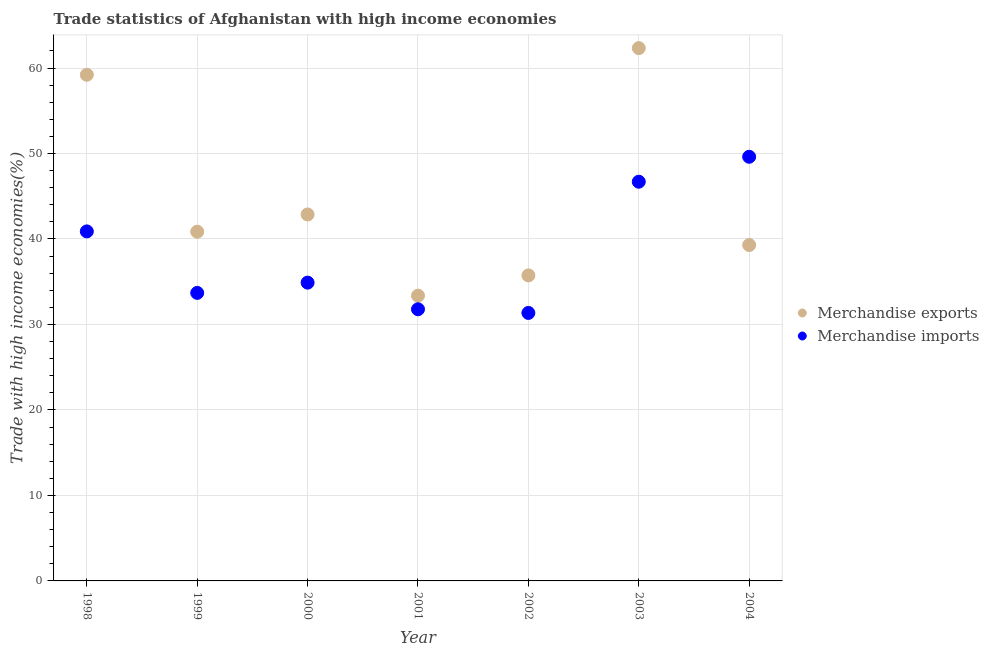Is the number of dotlines equal to the number of legend labels?
Offer a terse response. Yes. What is the merchandise exports in 2001?
Give a very brief answer. 33.37. Across all years, what is the maximum merchandise imports?
Offer a terse response. 49.62. Across all years, what is the minimum merchandise imports?
Offer a terse response. 31.35. In which year was the merchandise exports maximum?
Your response must be concise. 2003. In which year was the merchandise exports minimum?
Your response must be concise. 2001. What is the total merchandise exports in the graph?
Make the answer very short. 313.66. What is the difference between the merchandise exports in 1999 and that in 2000?
Make the answer very short. -2.02. What is the difference between the merchandise imports in 2002 and the merchandise exports in 2000?
Offer a very short reply. -11.52. What is the average merchandise imports per year?
Keep it short and to the point. 38.42. In the year 1999, what is the difference between the merchandise imports and merchandise exports?
Provide a succinct answer. -7.16. In how many years, is the merchandise imports greater than 34 %?
Make the answer very short. 4. What is the ratio of the merchandise imports in 1998 to that in 2000?
Provide a succinct answer. 1.17. Is the merchandise exports in 1999 less than that in 2003?
Your response must be concise. Yes. Is the difference between the merchandise imports in 1999 and 2004 greater than the difference between the merchandise exports in 1999 and 2004?
Ensure brevity in your answer.  No. What is the difference between the highest and the second highest merchandise imports?
Your answer should be very brief. 2.92. What is the difference between the highest and the lowest merchandise imports?
Offer a terse response. 18.27. How many dotlines are there?
Give a very brief answer. 2. How many years are there in the graph?
Keep it short and to the point. 7. What is the difference between two consecutive major ticks on the Y-axis?
Offer a very short reply. 10. Does the graph contain grids?
Your answer should be very brief. Yes. Where does the legend appear in the graph?
Offer a terse response. Center right. How many legend labels are there?
Your response must be concise. 2. What is the title of the graph?
Your answer should be very brief. Trade statistics of Afghanistan with high income economies. What is the label or title of the X-axis?
Offer a terse response. Year. What is the label or title of the Y-axis?
Make the answer very short. Trade with high income economies(%). What is the Trade with high income economies(%) of Merchandise exports in 1998?
Your answer should be compact. 59.21. What is the Trade with high income economies(%) in Merchandise imports in 1998?
Your answer should be very brief. 40.89. What is the Trade with high income economies(%) in Merchandise exports in 1999?
Provide a short and direct response. 40.85. What is the Trade with high income economies(%) in Merchandise imports in 1999?
Offer a very short reply. 33.69. What is the Trade with high income economies(%) in Merchandise exports in 2000?
Offer a very short reply. 42.87. What is the Trade with high income economies(%) in Merchandise imports in 2000?
Provide a short and direct response. 34.89. What is the Trade with high income economies(%) of Merchandise exports in 2001?
Offer a terse response. 33.37. What is the Trade with high income economies(%) of Merchandise imports in 2001?
Your answer should be compact. 31.78. What is the Trade with high income economies(%) of Merchandise exports in 2002?
Offer a very short reply. 35.74. What is the Trade with high income economies(%) in Merchandise imports in 2002?
Provide a succinct answer. 31.35. What is the Trade with high income economies(%) of Merchandise exports in 2003?
Your response must be concise. 62.33. What is the Trade with high income economies(%) of Merchandise imports in 2003?
Your answer should be very brief. 46.7. What is the Trade with high income economies(%) in Merchandise exports in 2004?
Your answer should be compact. 39.29. What is the Trade with high income economies(%) in Merchandise imports in 2004?
Keep it short and to the point. 49.62. Across all years, what is the maximum Trade with high income economies(%) in Merchandise exports?
Your response must be concise. 62.33. Across all years, what is the maximum Trade with high income economies(%) in Merchandise imports?
Ensure brevity in your answer.  49.62. Across all years, what is the minimum Trade with high income economies(%) in Merchandise exports?
Give a very brief answer. 33.37. Across all years, what is the minimum Trade with high income economies(%) in Merchandise imports?
Keep it short and to the point. 31.35. What is the total Trade with high income economies(%) in Merchandise exports in the graph?
Ensure brevity in your answer.  313.66. What is the total Trade with high income economies(%) in Merchandise imports in the graph?
Give a very brief answer. 268.91. What is the difference between the Trade with high income economies(%) of Merchandise exports in 1998 and that in 1999?
Ensure brevity in your answer.  18.35. What is the difference between the Trade with high income economies(%) in Merchandise imports in 1998 and that in 1999?
Your answer should be very brief. 7.19. What is the difference between the Trade with high income economies(%) of Merchandise exports in 1998 and that in 2000?
Offer a terse response. 16.34. What is the difference between the Trade with high income economies(%) of Merchandise imports in 1998 and that in 2000?
Offer a very short reply. 5.99. What is the difference between the Trade with high income economies(%) of Merchandise exports in 1998 and that in 2001?
Give a very brief answer. 25.84. What is the difference between the Trade with high income economies(%) of Merchandise imports in 1998 and that in 2001?
Your answer should be very brief. 9.11. What is the difference between the Trade with high income economies(%) in Merchandise exports in 1998 and that in 2002?
Offer a very short reply. 23.47. What is the difference between the Trade with high income economies(%) of Merchandise imports in 1998 and that in 2002?
Offer a terse response. 9.54. What is the difference between the Trade with high income economies(%) in Merchandise exports in 1998 and that in 2003?
Provide a succinct answer. -3.12. What is the difference between the Trade with high income economies(%) in Merchandise imports in 1998 and that in 2003?
Give a very brief answer. -5.81. What is the difference between the Trade with high income economies(%) in Merchandise exports in 1998 and that in 2004?
Provide a succinct answer. 19.91. What is the difference between the Trade with high income economies(%) in Merchandise imports in 1998 and that in 2004?
Provide a succinct answer. -8.73. What is the difference between the Trade with high income economies(%) of Merchandise exports in 1999 and that in 2000?
Keep it short and to the point. -2.02. What is the difference between the Trade with high income economies(%) of Merchandise imports in 1999 and that in 2000?
Ensure brevity in your answer.  -1.2. What is the difference between the Trade with high income economies(%) of Merchandise exports in 1999 and that in 2001?
Keep it short and to the point. 7.48. What is the difference between the Trade with high income economies(%) of Merchandise imports in 1999 and that in 2001?
Keep it short and to the point. 1.91. What is the difference between the Trade with high income economies(%) in Merchandise exports in 1999 and that in 2002?
Offer a terse response. 5.11. What is the difference between the Trade with high income economies(%) in Merchandise imports in 1999 and that in 2002?
Offer a terse response. 2.34. What is the difference between the Trade with high income economies(%) in Merchandise exports in 1999 and that in 2003?
Give a very brief answer. -21.47. What is the difference between the Trade with high income economies(%) in Merchandise imports in 1999 and that in 2003?
Your response must be concise. -13.01. What is the difference between the Trade with high income economies(%) in Merchandise exports in 1999 and that in 2004?
Your answer should be compact. 1.56. What is the difference between the Trade with high income economies(%) in Merchandise imports in 1999 and that in 2004?
Give a very brief answer. -15.92. What is the difference between the Trade with high income economies(%) of Merchandise exports in 2000 and that in 2001?
Your answer should be very brief. 9.5. What is the difference between the Trade with high income economies(%) in Merchandise imports in 2000 and that in 2001?
Give a very brief answer. 3.11. What is the difference between the Trade with high income economies(%) of Merchandise exports in 2000 and that in 2002?
Keep it short and to the point. 7.13. What is the difference between the Trade with high income economies(%) of Merchandise imports in 2000 and that in 2002?
Offer a terse response. 3.54. What is the difference between the Trade with high income economies(%) in Merchandise exports in 2000 and that in 2003?
Make the answer very short. -19.46. What is the difference between the Trade with high income economies(%) in Merchandise imports in 2000 and that in 2003?
Offer a very short reply. -11.8. What is the difference between the Trade with high income economies(%) in Merchandise exports in 2000 and that in 2004?
Offer a very short reply. 3.58. What is the difference between the Trade with high income economies(%) of Merchandise imports in 2000 and that in 2004?
Your response must be concise. -14.72. What is the difference between the Trade with high income economies(%) of Merchandise exports in 2001 and that in 2002?
Your answer should be very brief. -2.37. What is the difference between the Trade with high income economies(%) in Merchandise imports in 2001 and that in 2002?
Keep it short and to the point. 0.43. What is the difference between the Trade with high income economies(%) of Merchandise exports in 2001 and that in 2003?
Your answer should be very brief. -28.96. What is the difference between the Trade with high income economies(%) of Merchandise imports in 2001 and that in 2003?
Offer a terse response. -14.92. What is the difference between the Trade with high income economies(%) in Merchandise exports in 2001 and that in 2004?
Keep it short and to the point. -5.92. What is the difference between the Trade with high income economies(%) of Merchandise imports in 2001 and that in 2004?
Keep it short and to the point. -17.84. What is the difference between the Trade with high income economies(%) of Merchandise exports in 2002 and that in 2003?
Your response must be concise. -26.59. What is the difference between the Trade with high income economies(%) of Merchandise imports in 2002 and that in 2003?
Ensure brevity in your answer.  -15.35. What is the difference between the Trade with high income economies(%) in Merchandise exports in 2002 and that in 2004?
Keep it short and to the point. -3.55. What is the difference between the Trade with high income economies(%) in Merchandise imports in 2002 and that in 2004?
Keep it short and to the point. -18.27. What is the difference between the Trade with high income economies(%) of Merchandise exports in 2003 and that in 2004?
Provide a short and direct response. 23.03. What is the difference between the Trade with high income economies(%) in Merchandise imports in 2003 and that in 2004?
Your answer should be very brief. -2.92. What is the difference between the Trade with high income economies(%) of Merchandise exports in 1998 and the Trade with high income economies(%) of Merchandise imports in 1999?
Provide a short and direct response. 25.51. What is the difference between the Trade with high income economies(%) of Merchandise exports in 1998 and the Trade with high income economies(%) of Merchandise imports in 2000?
Offer a terse response. 24.31. What is the difference between the Trade with high income economies(%) in Merchandise exports in 1998 and the Trade with high income economies(%) in Merchandise imports in 2001?
Provide a short and direct response. 27.43. What is the difference between the Trade with high income economies(%) of Merchandise exports in 1998 and the Trade with high income economies(%) of Merchandise imports in 2002?
Offer a terse response. 27.86. What is the difference between the Trade with high income economies(%) of Merchandise exports in 1998 and the Trade with high income economies(%) of Merchandise imports in 2003?
Keep it short and to the point. 12.51. What is the difference between the Trade with high income economies(%) of Merchandise exports in 1998 and the Trade with high income economies(%) of Merchandise imports in 2004?
Ensure brevity in your answer.  9.59. What is the difference between the Trade with high income economies(%) in Merchandise exports in 1999 and the Trade with high income economies(%) in Merchandise imports in 2000?
Your answer should be compact. 5.96. What is the difference between the Trade with high income economies(%) of Merchandise exports in 1999 and the Trade with high income economies(%) of Merchandise imports in 2001?
Your answer should be compact. 9.07. What is the difference between the Trade with high income economies(%) of Merchandise exports in 1999 and the Trade with high income economies(%) of Merchandise imports in 2002?
Your answer should be compact. 9.5. What is the difference between the Trade with high income economies(%) in Merchandise exports in 1999 and the Trade with high income economies(%) in Merchandise imports in 2003?
Your response must be concise. -5.85. What is the difference between the Trade with high income economies(%) of Merchandise exports in 1999 and the Trade with high income economies(%) of Merchandise imports in 2004?
Make the answer very short. -8.76. What is the difference between the Trade with high income economies(%) of Merchandise exports in 2000 and the Trade with high income economies(%) of Merchandise imports in 2001?
Keep it short and to the point. 11.09. What is the difference between the Trade with high income economies(%) in Merchandise exports in 2000 and the Trade with high income economies(%) in Merchandise imports in 2002?
Offer a terse response. 11.52. What is the difference between the Trade with high income economies(%) of Merchandise exports in 2000 and the Trade with high income economies(%) of Merchandise imports in 2003?
Give a very brief answer. -3.83. What is the difference between the Trade with high income economies(%) of Merchandise exports in 2000 and the Trade with high income economies(%) of Merchandise imports in 2004?
Keep it short and to the point. -6.75. What is the difference between the Trade with high income economies(%) of Merchandise exports in 2001 and the Trade with high income economies(%) of Merchandise imports in 2002?
Ensure brevity in your answer.  2.02. What is the difference between the Trade with high income economies(%) in Merchandise exports in 2001 and the Trade with high income economies(%) in Merchandise imports in 2003?
Provide a short and direct response. -13.33. What is the difference between the Trade with high income economies(%) of Merchandise exports in 2001 and the Trade with high income economies(%) of Merchandise imports in 2004?
Offer a very short reply. -16.25. What is the difference between the Trade with high income economies(%) in Merchandise exports in 2002 and the Trade with high income economies(%) in Merchandise imports in 2003?
Ensure brevity in your answer.  -10.96. What is the difference between the Trade with high income economies(%) of Merchandise exports in 2002 and the Trade with high income economies(%) of Merchandise imports in 2004?
Keep it short and to the point. -13.88. What is the difference between the Trade with high income economies(%) in Merchandise exports in 2003 and the Trade with high income economies(%) in Merchandise imports in 2004?
Your response must be concise. 12.71. What is the average Trade with high income economies(%) in Merchandise exports per year?
Offer a terse response. 44.81. What is the average Trade with high income economies(%) in Merchandise imports per year?
Offer a terse response. 38.42. In the year 1998, what is the difference between the Trade with high income economies(%) in Merchandise exports and Trade with high income economies(%) in Merchandise imports?
Give a very brief answer. 18.32. In the year 1999, what is the difference between the Trade with high income economies(%) of Merchandise exports and Trade with high income economies(%) of Merchandise imports?
Your answer should be compact. 7.16. In the year 2000, what is the difference between the Trade with high income economies(%) in Merchandise exports and Trade with high income economies(%) in Merchandise imports?
Give a very brief answer. 7.98. In the year 2001, what is the difference between the Trade with high income economies(%) in Merchandise exports and Trade with high income economies(%) in Merchandise imports?
Offer a terse response. 1.59. In the year 2002, what is the difference between the Trade with high income economies(%) in Merchandise exports and Trade with high income economies(%) in Merchandise imports?
Provide a short and direct response. 4.39. In the year 2003, what is the difference between the Trade with high income economies(%) in Merchandise exports and Trade with high income economies(%) in Merchandise imports?
Offer a very short reply. 15.63. In the year 2004, what is the difference between the Trade with high income economies(%) in Merchandise exports and Trade with high income economies(%) in Merchandise imports?
Offer a terse response. -10.32. What is the ratio of the Trade with high income economies(%) of Merchandise exports in 1998 to that in 1999?
Offer a very short reply. 1.45. What is the ratio of the Trade with high income economies(%) of Merchandise imports in 1998 to that in 1999?
Make the answer very short. 1.21. What is the ratio of the Trade with high income economies(%) of Merchandise exports in 1998 to that in 2000?
Your answer should be very brief. 1.38. What is the ratio of the Trade with high income economies(%) in Merchandise imports in 1998 to that in 2000?
Your answer should be very brief. 1.17. What is the ratio of the Trade with high income economies(%) of Merchandise exports in 1998 to that in 2001?
Your answer should be compact. 1.77. What is the ratio of the Trade with high income economies(%) of Merchandise imports in 1998 to that in 2001?
Provide a short and direct response. 1.29. What is the ratio of the Trade with high income economies(%) in Merchandise exports in 1998 to that in 2002?
Keep it short and to the point. 1.66. What is the ratio of the Trade with high income economies(%) in Merchandise imports in 1998 to that in 2002?
Your response must be concise. 1.3. What is the ratio of the Trade with high income economies(%) of Merchandise exports in 1998 to that in 2003?
Your answer should be very brief. 0.95. What is the ratio of the Trade with high income economies(%) in Merchandise imports in 1998 to that in 2003?
Your response must be concise. 0.88. What is the ratio of the Trade with high income economies(%) in Merchandise exports in 1998 to that in 2004?
Offer a very short reply. 1.51. What is the ratio of the Trade with high income economies(%) in Merchandise imports in 1998 to that in 2004?
Ensure brevity in your answer.  0.82. What is the ratio of the Trade with high income economies(%) in Merchandise exports in 1999 to that in 2000?
Your answer should be compact. 0.95. What is the ratio of the Trade with high income economies(%) of Merchandise imports in 1999 to that in 2000?
Your response must be concise. 0.97. What is the ratio of the Trade with high income economies(%) of Merchandise exports in 1999 to that in 2001?
Offer a terse response. 1.22. What is the ratio of the Trade with high income economies(%) of Merchandise imports in 1999 to that in 2001?
Your answer should be very brief. 1.06. What is the ratio of the Trade with high income economies(%) in Merchandise exports in 1999 to that in 2002?
Offer a very short reply. 1.14. What is the ratio of the Trade with high income economies(%) in Merchandise imports in 1999 to that in 2002?
Offer a very short reply. 1.07. What is the ratio of the Trade with high income economies(%) of Merchandise exports in 1999 to that in 2003?
Offer a very short reply. 0.66. What is the ratio of the Trade with high income economies(%) in Merchandise imports in 1999 to that in 2003?
Give a very brief answer. 0.72. What is the ratio of the Trade with high income economies(%) in Merchandise exports in 1999 to that in 2004?
Provide a short and direct response. 1.04. What is the ratio of the Trade with high income economies(%) of Merchandise imports in 1999 to that in 2004?
Offer a very short reply. 0.68. What is the ratio of the Trade with high income economies(%) in Merchandise exports in 2000 to that in 2001?
Your response must be concise. 1.28. What is the ratio of the Trade with high income economies(%) of Merchandise imports in 2000 to that in 2001?
Provide a succinct answer. 1.1. What is the ratio of the Trade with high income economies(%) in Merchandise exports in 2000 to that in 2002?
Your answer should be compact. 1.2. What is the ratio of the Trade with high income economies(%) in Merchandise imports in 2000 to that in 2002?
Keep it short and to the point. 1.11. What is the ratio of the Trade with high income economies(%) in Merchandise exports in 2000 to that in 2003?
Keep it short and to the point. 0.69. What is the ratio of the Trade with high income economies(%) of Merchandise imports in 2000 to that in 2003?
Your answer should be very brief. 0.75. What is the ratio of the Trade with high income economies(%) of Merchandise exports in 2000 to that in 2004?
Provide a succinct answer. 1.09. What is the ratio of the Trade with high income economies(%) of Merchandise imports in 2000 to that in 2004?
Offer a terse response. 0.7. What is the ratio of the Trade with high income economies(%) of Merchandise exports in 2001 to that in 2002?
Give a very brief answer. 0.93. What is the ratio of the Trade with high income economies(%) of Merchandise imports in 2001 to that in 2002?
Keep it short and to the point. 1.01. What is the ratio of the Trade with high income economies(%) of Merchandise exports in 2001 to that in 2003?
Give a very brief answer. 0.54. What is the ratio of the Trade with high income economies(%) in Merchandise imports in 2001 to that in 2003?
Ensure brevity in your answer.  0.68. What is the ratio of the Trade with high income economies(%) in Merchandise exports in 2001 to that in 2004?
Offer a very short reply. 0.85. What is the ratio of the Trade with high income economies(%) of Merchandise imports in 2001 to that in 2004?
Keep it short and to the point. 0.64. What is the ratio of the Trade with high income economies(%) in Merchandise exports in 2002 to that in 2003?
Offer a terse response. 0.57. What is the ratio of the Trade with high income economies(%) in Merchandise imports in 2002 to that in 2003?
Your answer should be very brief. 0.67. What is the ratio of the Trade with high income economies(%) in Merchandise exports in 2002 to that in 2004?
Your response must be concise. 0.91. What is the ratio of the Trade with high income economies(%) in Merchandise imports in 2002 to that in 2004?
Keep it short and to the point. 0.63. What is the ratio of the Trade with high income economies(%) in Merchandise exports in 2003 to that in 2004?
Make the answer very short. 1.59. What is the ratio of the Trade with high income economies(%) in Merchandise imports in 2003 to that in 2004?
Provide a short and direct response. 0.94. What is the difference between the highest and the second highest Trade with high income economies(%) of Merchandise exports?
Your response must be concise. 3.12. What is the difference between the highest and the second highest Trade with high income economies(%) of Merchandise imports?
Your answer should be compact. 2.92. What is the difference between the highest and the lowest Trade with high income economies(%) of Merchandise exports?
Offer a terse response. 28.96. What is the difference between the highest and the lowest Trade with high income economies(%) of Merchandise imports?
Provide a short and direct response. 18.27. 